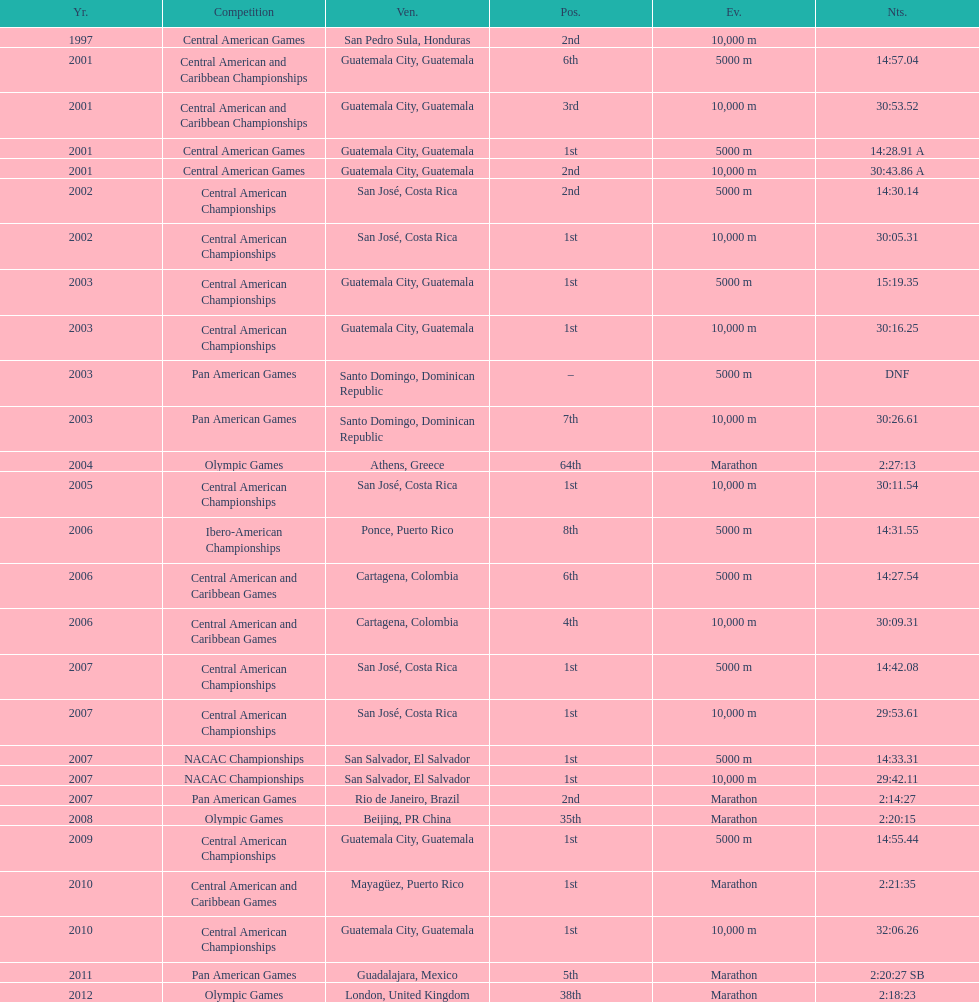Tell me the number of times they competed in guatamala. 5. 